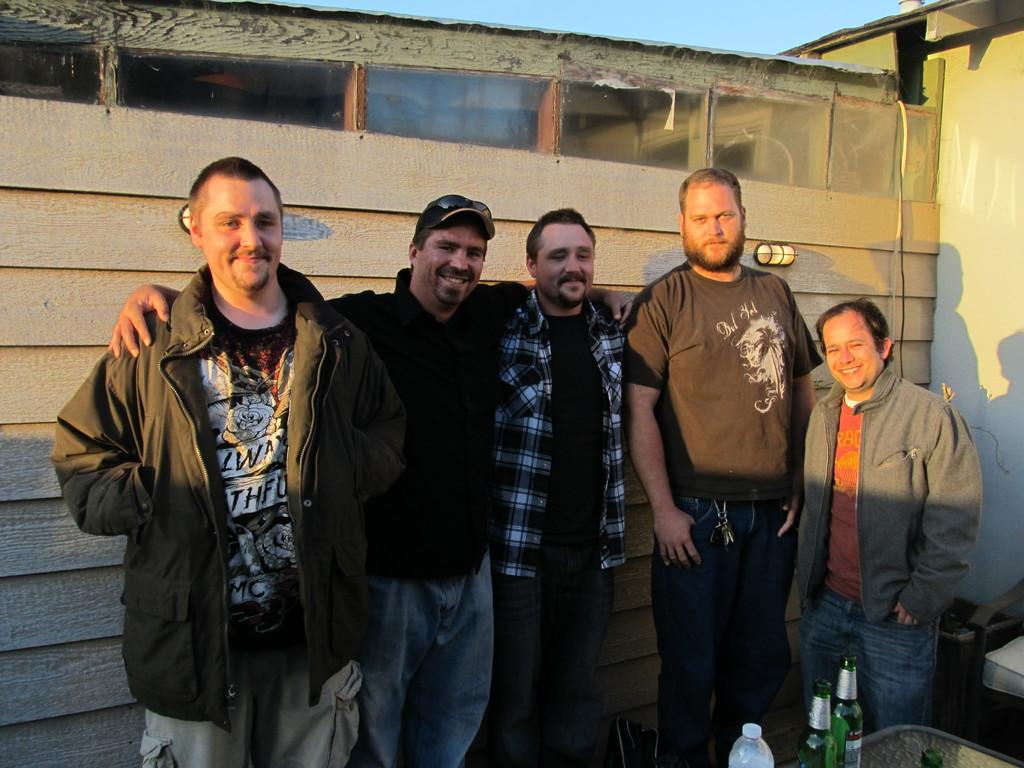How many men are present in the image? There are five men standing in the image. What is in front of the men? There is a table in front of the men. What can be seen on the table? There are bottles on the table. What can be seen in the background of the image? There is a wooden wall in the background of the image. Where is the faucet located in the image? There is no faucet present in the image. What type of prison can be seen in the background of the image? There is no prison visible in the image; it features a wooden wall in the background. 